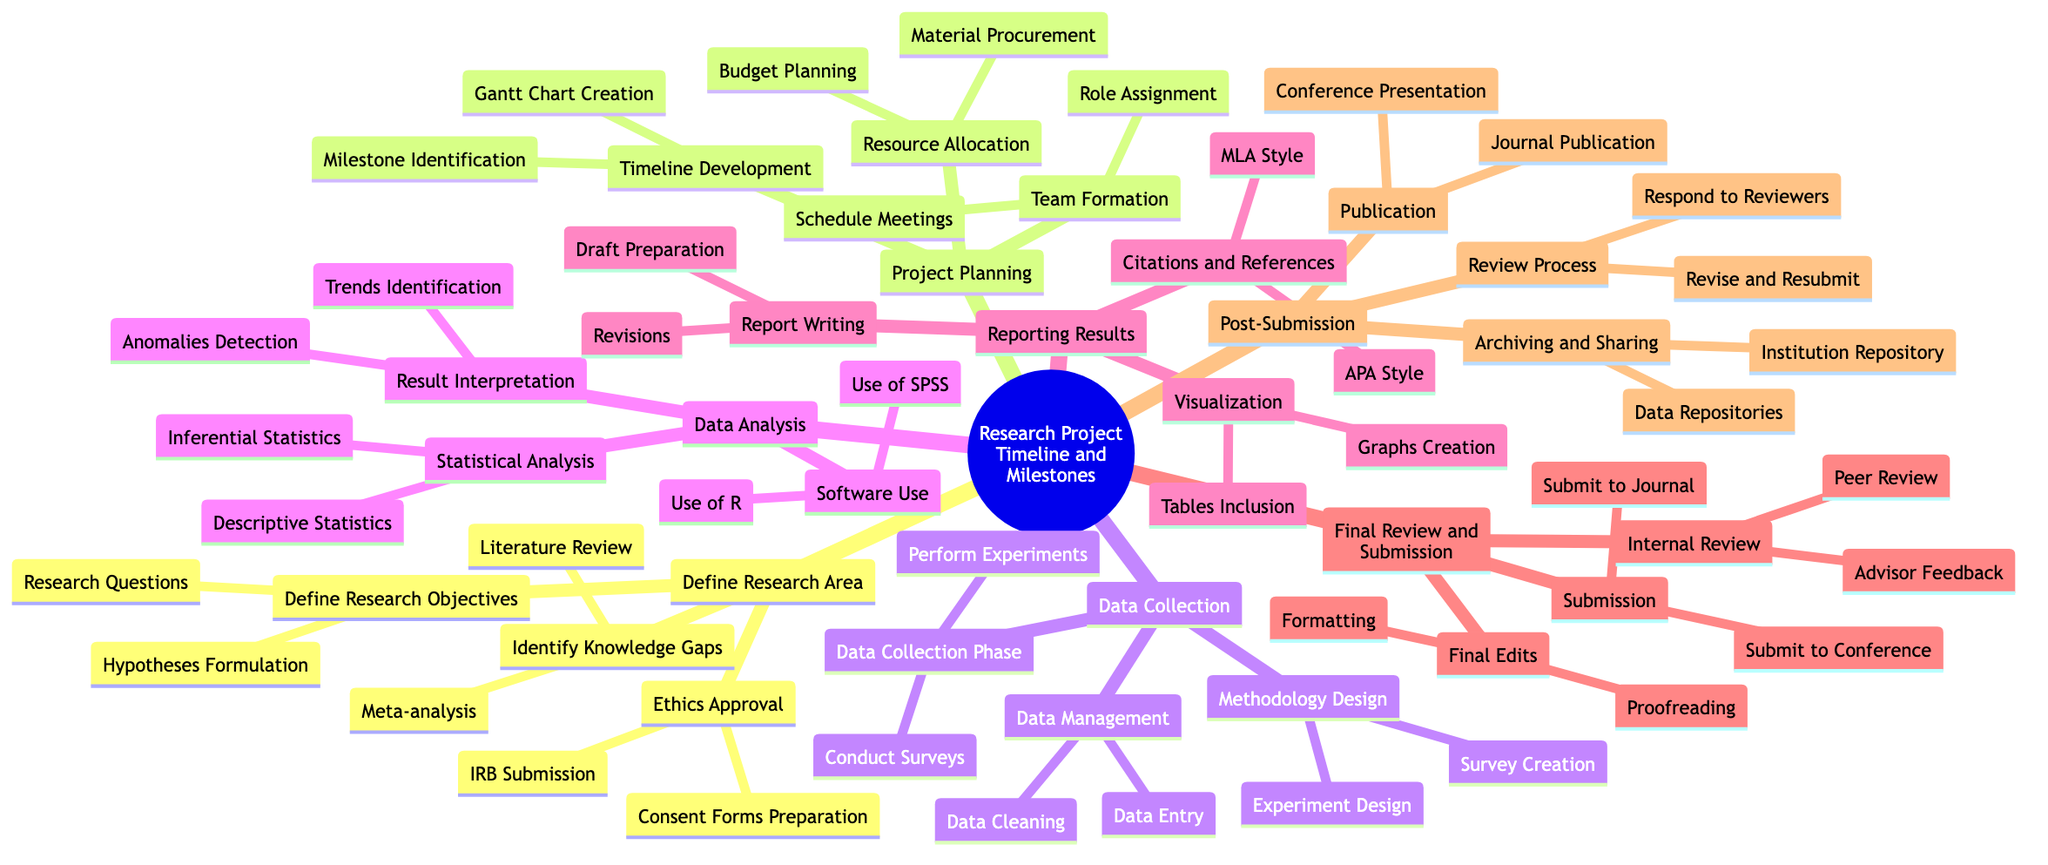What is the first major category in the diagram? The first major category is the topmost node labeled "Define Research Area." By examining the structure of the mind map, the first node encountered directly branching from the root is this category.
Answer: Define Research Area How many subcategories are under "Data Collection"? Under "Data Collection," there are three subcategories: "Methodology Design," "Data Collection Phase," and "Data Management." By counting these branches, it is determined that the total is three.
Answer: 3 What milestone comes after "Submit to Journal"? The milestone that comes after "Submit to Journal" is "Submit to Conference." This is identified by following the branches from "Submission," where both submission actions are listed sequentially.
Answer: Submit to Conference What are the two main tasks associated with "Reporting Results"? The two main tasks associated with "Reporting Results" are "Report Writing" and "Visualization." These are the immediate branches stemming from the "Reporting Results" category in the mind map.
Answer: Report Writing and Visualization Which analysis type is included in "Data Analysis"? "Inferential Statistics" is one of the analysis types included in "Data Analysis." By reviewing the first level of tasks within "Data Analysis," it is listed clearly among the types of statistical analysis.
Answer: Inferential Statistics How does "Ethics Approval" relate to "Define Research Objectives"? "Ethics Approval" and "Define Research Objectives" are both subcategories under the main category "Define Research Area." This indicates they are at the same level in the hierarchy, implying they are both essential steps within the same phase of the research project.
Answer: They are both subcategories of "Define Research Area." What is the final step of the "Post-Submission" phase? The final step of the "Post-Submission" phase is "Archiving and Sharing." This is determined by reviewing the sequence of tasks listed in this phase, where "Archiving and Sharing" is the last branch listed.
Answer: Archiving and Sharing Which section includes "Gantt Chart Creation"? "Gantt Chart Creation" is included in the "Timeline Development" section. It can be identified as a component of the possible tasks listed under that specific subcategory.
Answer: Timeline Development What comes before "Proofreading" in the final review process? The task that comes before "Proofreading" in the final review process is "Final Edits." This task is a preceding node in the sequence of activities leading up to proofreading in the final stage.
Answer: Final Edits 